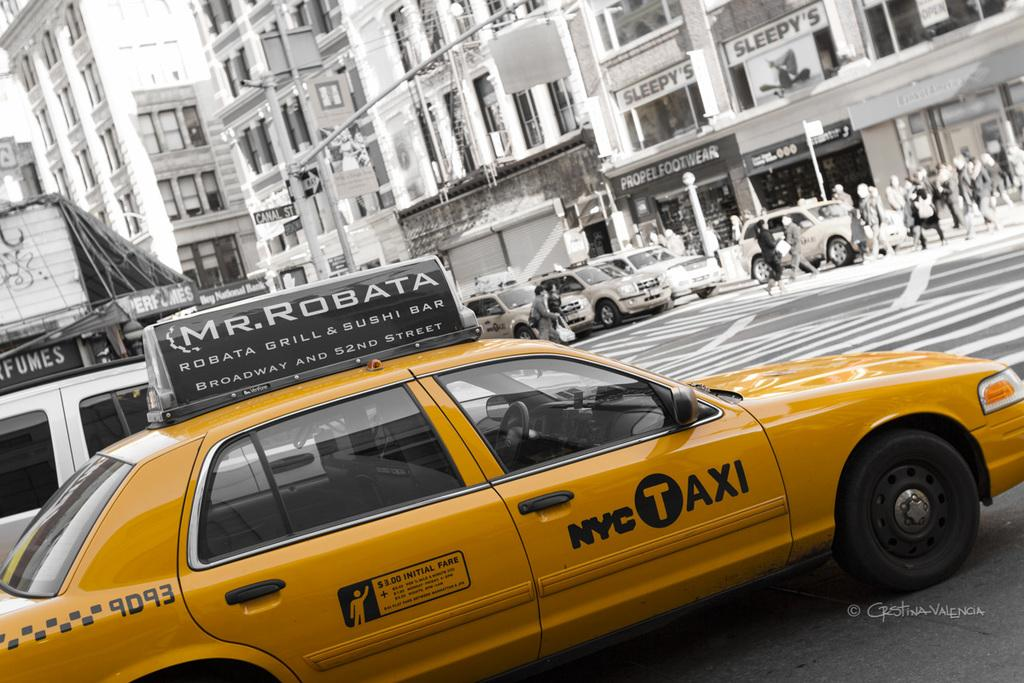<image>
Describe the image concisely. A yellow taxi cab advertises Mr. Robata on its roof. 